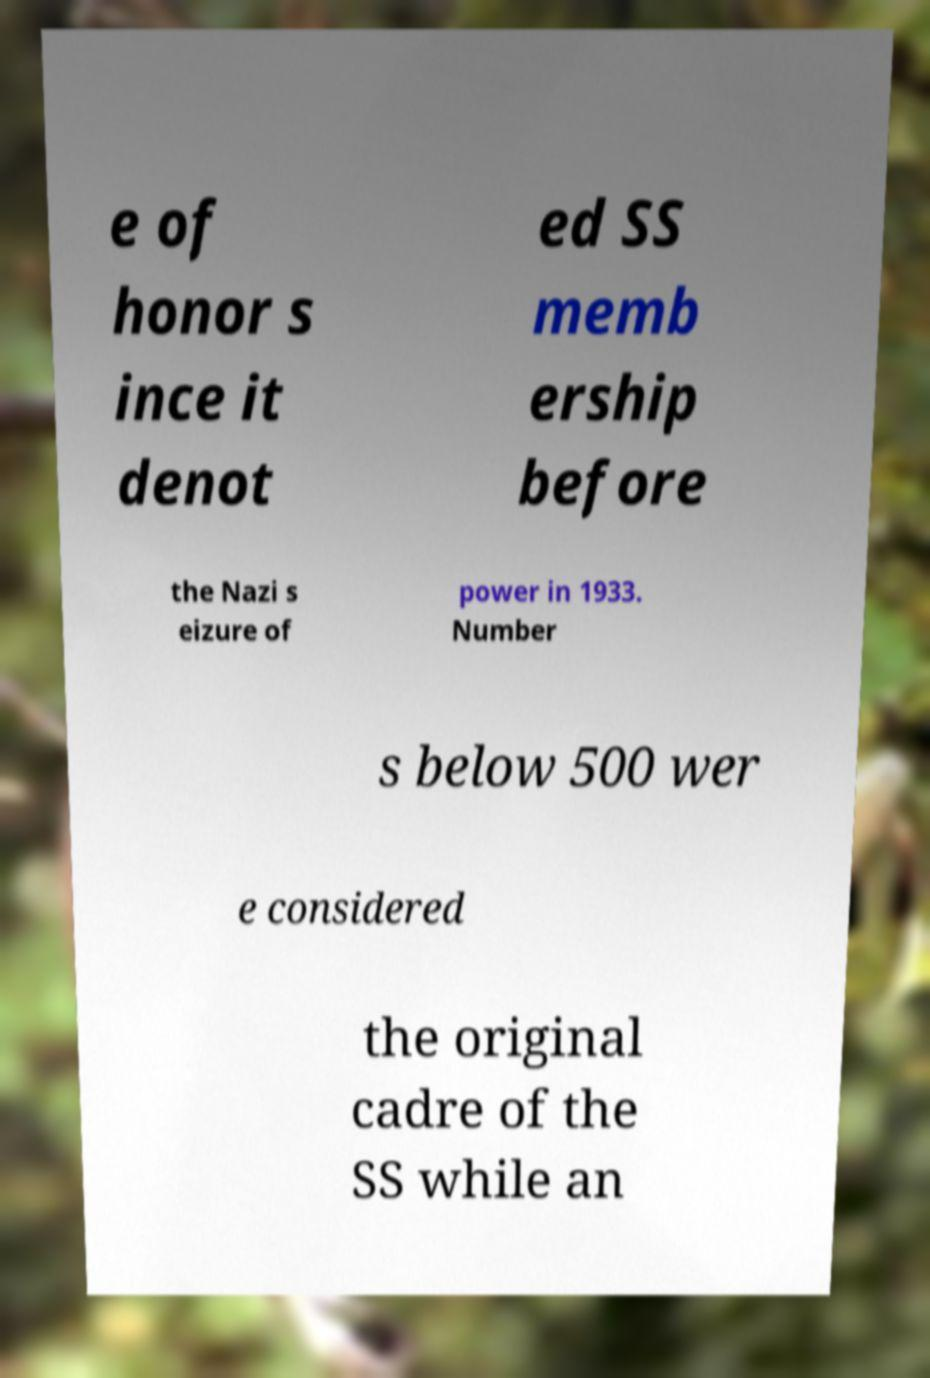Please read and relay the text visible in this image. What does it say? e of honor s ince it denot ed SS memb ership before the Nazi s eizure of power in 1933. Number s below 500 wer e considered the original cadre of the SS while an 